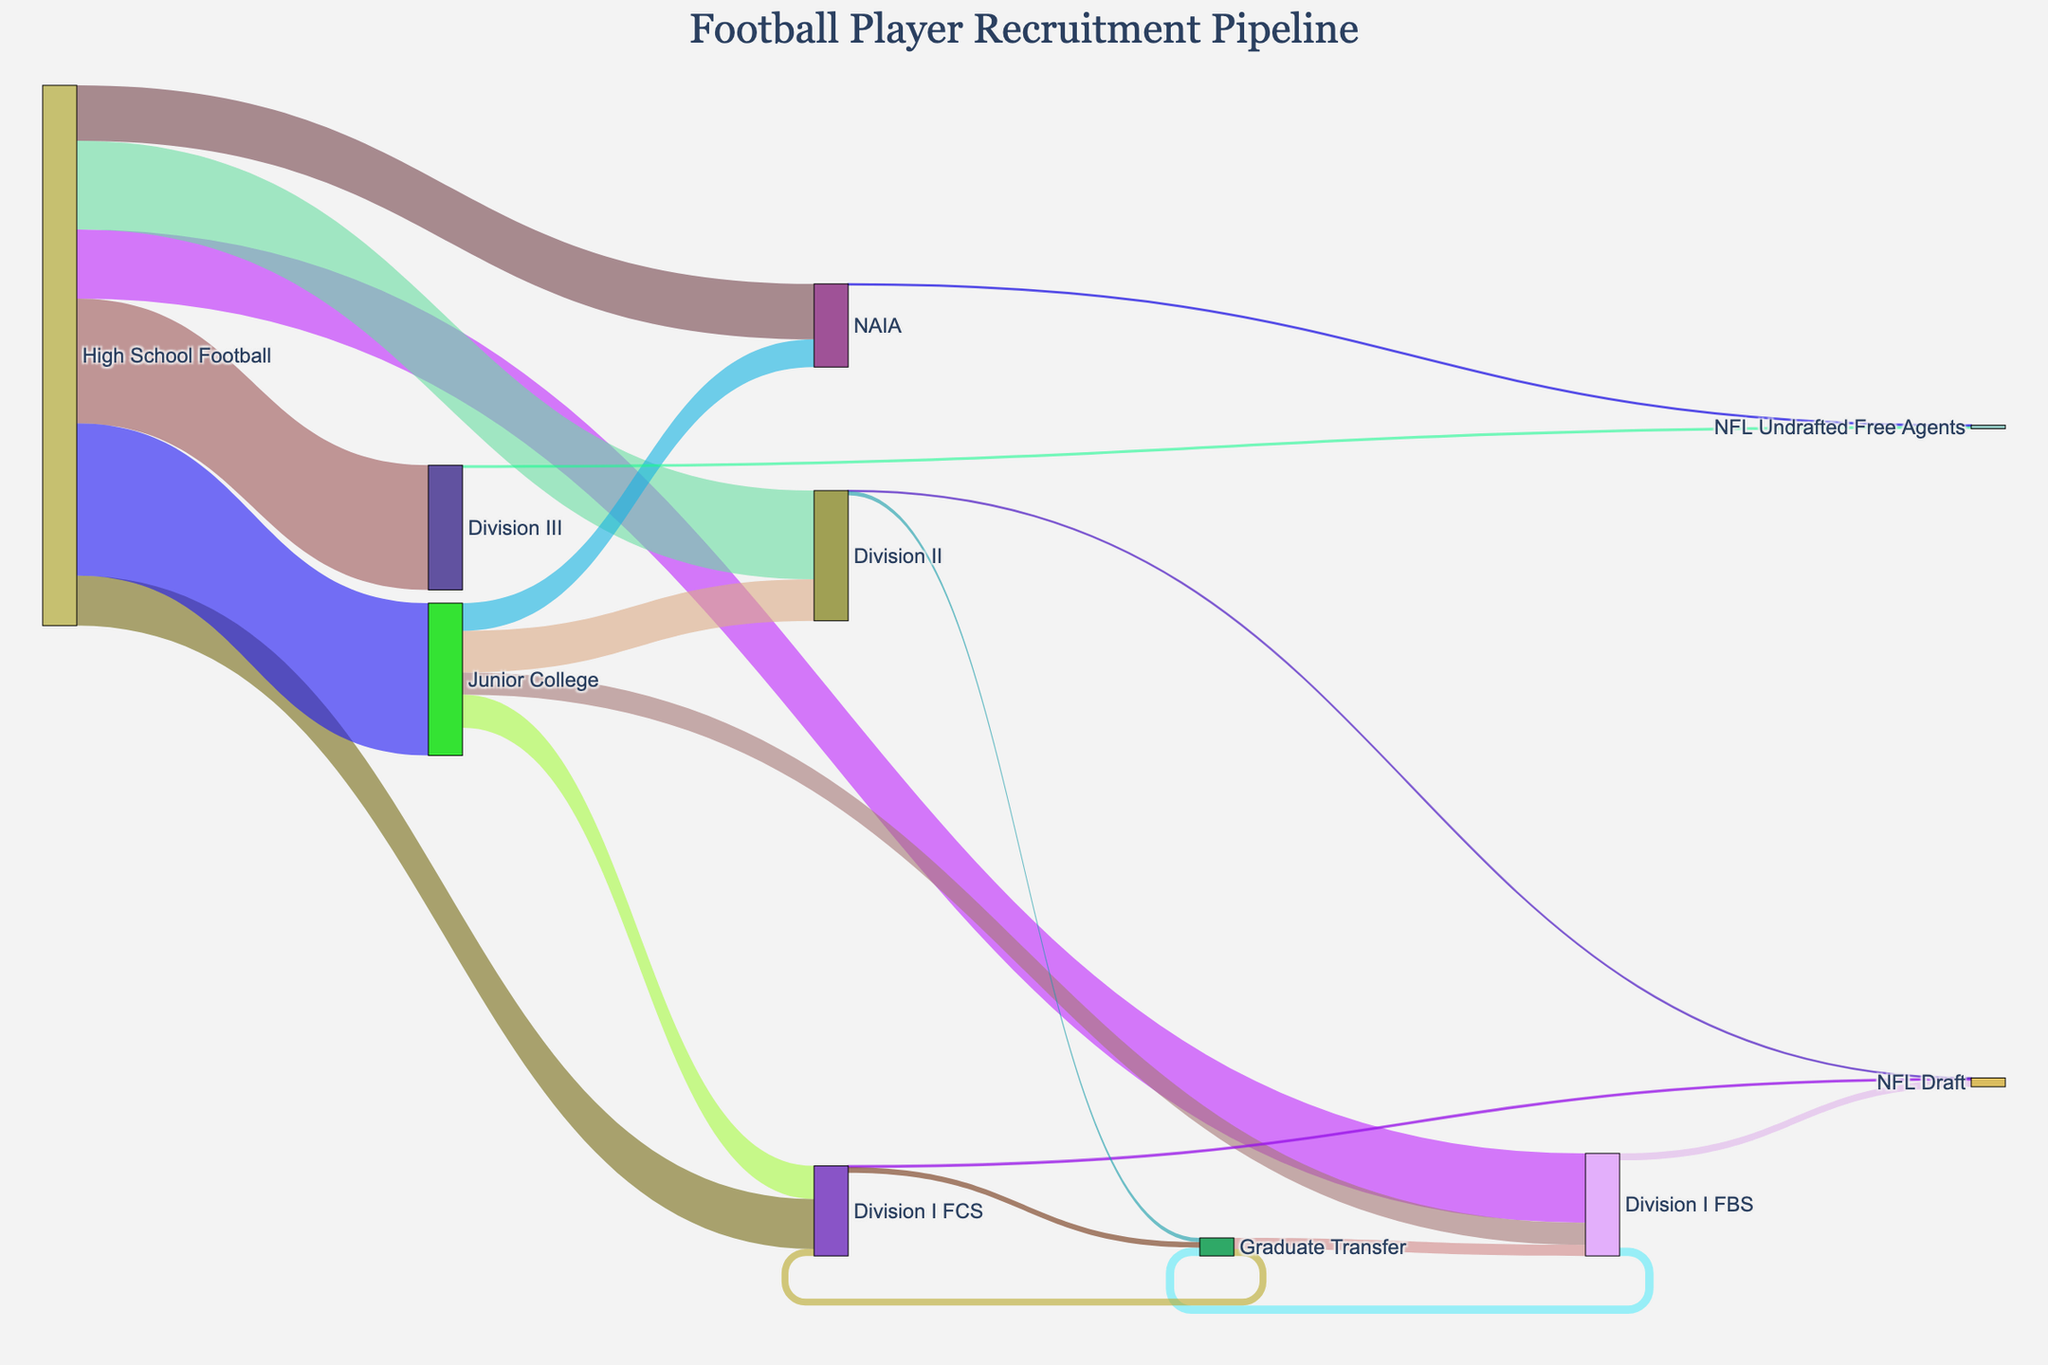What is the title of the Sankey diagram? The title of the Sankey diagram is typically displayed at the top-center of the diagram within the layout settings. According to the provided code, the title is "Football Player Recruitment Pipeline."
Answer: Football Player Recruitment Pipeline How many players transitioned from High School Football to Division III? To find this, locate "High School Football" as the source and "Division III" as the target in the diagram. The value associated with this path is shown in the data table as 4500.
Answer: 4500 Which recruitment path has the highest value starting from High School Football? Look at all the paths starting from "High School Football," and identify the one with the highest value. High School Football to Junior College has the highest value, which is 5500.
Answer: High School Football to Junior College How many players were drafted into the NFL from Division I FBS? Find "Division I FBS" as the source and "NFL Draft" as the target. The value for this path is 250 as indicated in the data table.
Answer: 250 Compare the number of players moving from Junior College to Division I FBS and Division I FCS. Which path has more players? Look for the paths from "Junior College" to "Division I FBS" and to "Division I FCS." The values are 800 and 1200, respectively. Division I FCS has more players.
Answer: Junior College to Division I FCS What's the total number of players who transferred to Division I FBS, including those via Graduate Transfer? First, identify all paths leading to "Division I FBS": directly from "High School Football," "Junior College," and "Graduate Transfer." Sum the values: 2500 (High School) + 800 (Junior College) + 400 (Graduate Transfer) = 3700.
Answer: 3700 How many players came from Graduate Transfer to Division I FBS compared to Division I FCS? Look for paths from "Graduate Transfer" to "Division I FBS" and "Division I FCS." The values are 400 and 250, respectively. Division I FBS has more players.
Answer: Division I FBS What is the total number of players entering professional identification, either through the NFL Draft or as Undrafted Free Agents? Sum the values for paths leading to either "NFL Draft" or "NFL Undrafted Free Agents": 250 (Division I FBS to NFL Draft) + 50 (Division I FCS to NFL Draft) + 20 (Division II to NFL Draft) + 100 (Division III to NFL Undrafted Free Agents) + 30 (NAIA to NFL Undrafted Free Agents) = 450.
Answer: 450 What is the sum of players transitioning from High School Football to any college division? Sum the values for all paths from "High School Football" to college divisions: 2500 (D-I FBS) + 1800 (D-I FCS) + 3200 (D-II) + 4500 (D-III) + 2000 (NAIA) + 5500 (Junior College) = 19500.
Answer: 19500 Which path has more players: High School to Division II or Junior College to Division II? Compare the values from "High School Football" to "Division II" (3200) and from "Junior College" to "Division II" (1500). The High School to Division II path has more players.
Answer: High School to Division II 